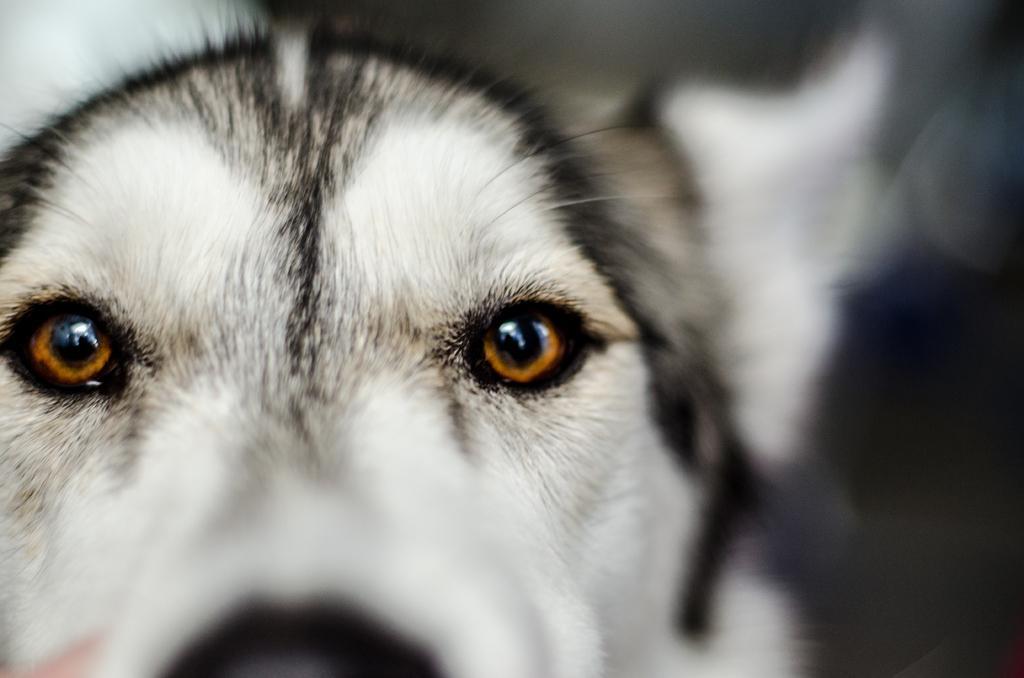Can you describe this image briefly? In this picture we can see a dog´s face in the front, we can see a blurry background. 